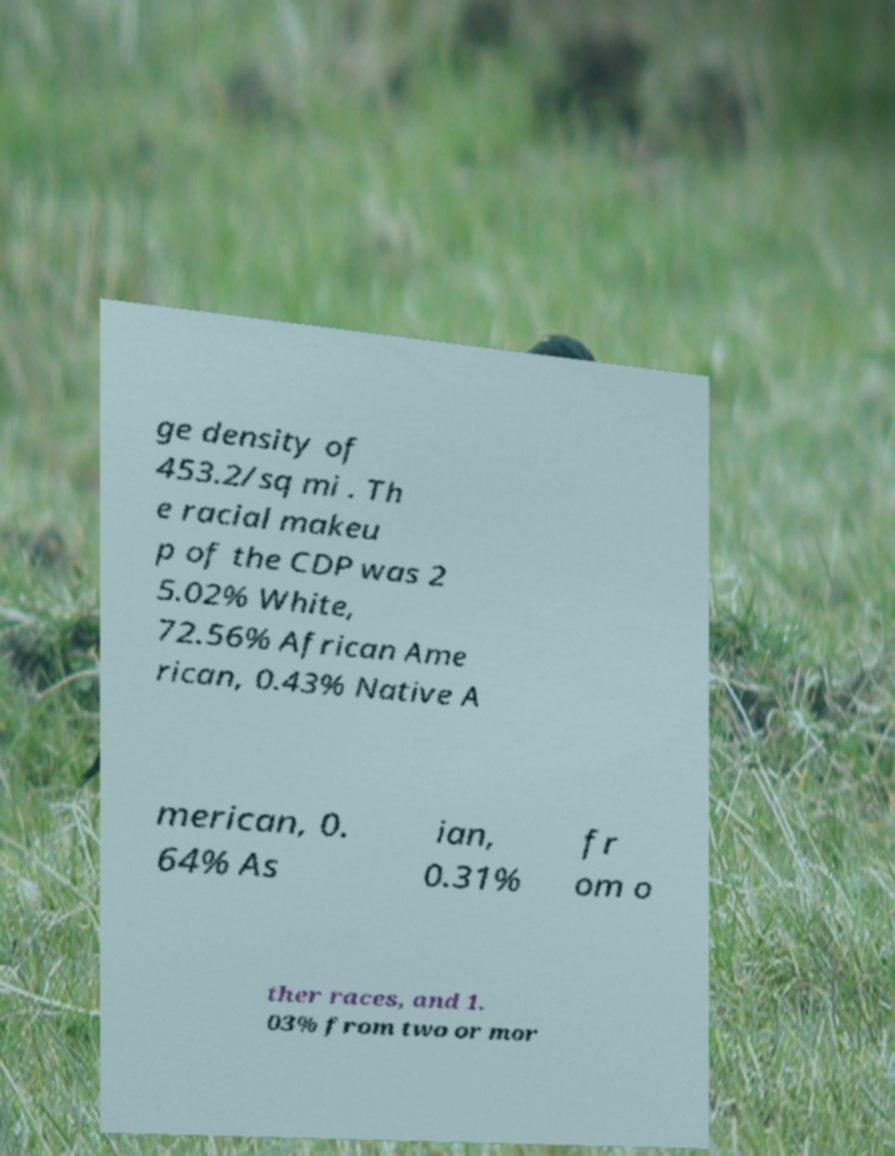Could you assist in decoding the text presented in this image and type it out clearly? ge density of 453.2/sq mi . Th e racial makeu p of the CDP was 2 5.02% White, 72.56% African Ame rican, 0.43% Native A merican, 0. 64% As ian, 0.31% fr om o ther races, and 1. 03% from two or mor 